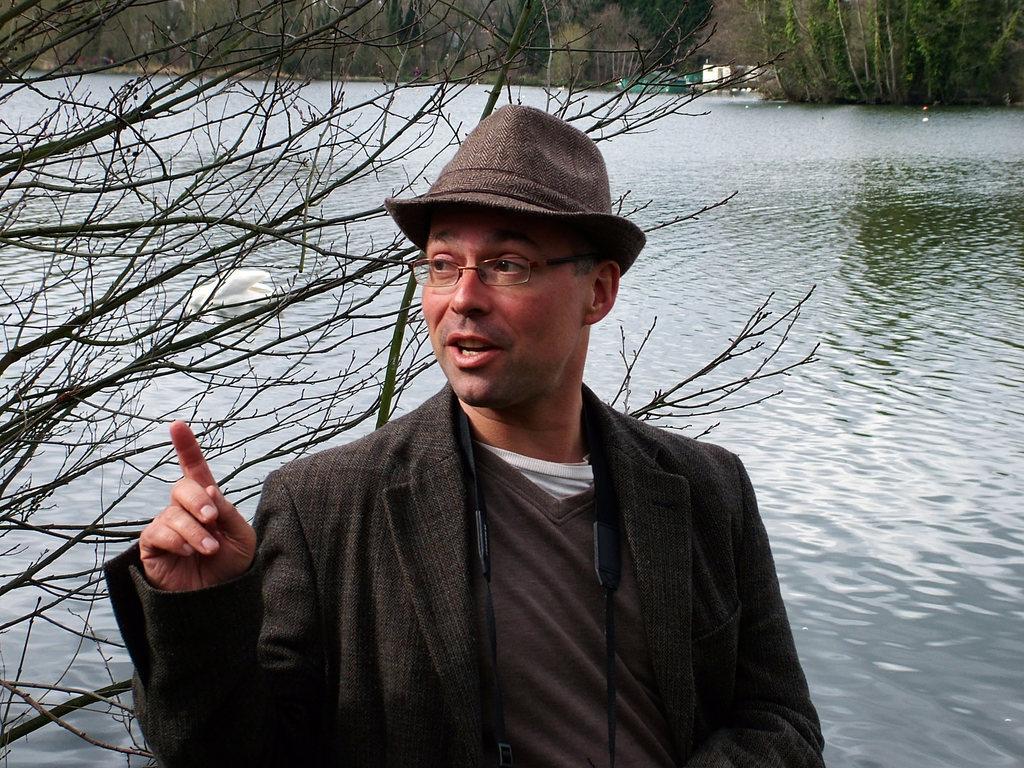How would you summarize this image in a sentence or two? In this image there is a person standing and looking to the left side of the image, behind the person there is a tree and there is an object in the river. In the background there are trees, in the middle of the trees there is a building. 